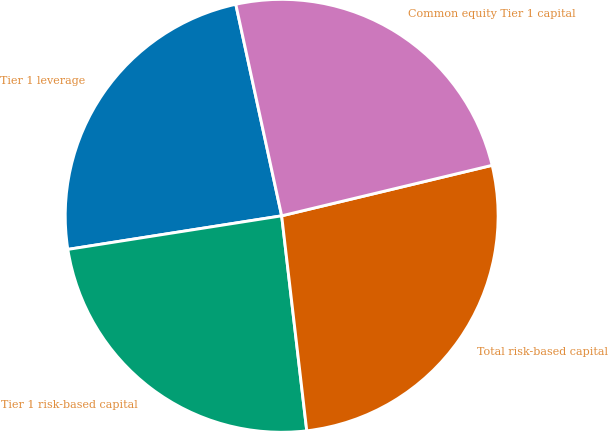Convert chart to OTSL. <chart><loc_0><loc_0><loc_500><loc_500><pie_chart><fcel>Tier 1 leverage<fcel>Tier 1 risk-based capital<fcel>Total risk-based capital<fcel>Common equity Tier 1 capital<nl><fcel>24.08%<fcel>24.37%<fcel>26.9%<fcel>24.65%<nl></chart> 